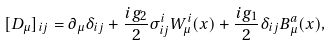Convert formula to latex. <formula><loc_0><loc_0><loc_500><loc_500>[ D _ { \mu } ] _ { i j } = \partial _ { \mu } \delta _ { i j } + \frac { i g _ { 2 } } { 2 } \sigma ^ { i } _ { i j } W ^ { i } _ { \mu } ( x ) + \frac { i g _ { 1 } } { 2 } \delta _ { i j } B ^ { a } _ { \mu } ( x ) ,</formula> 